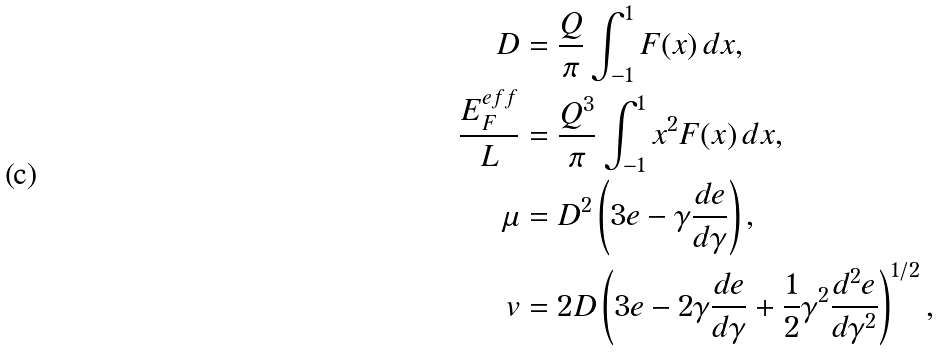Convert formula to latex. <formula><loc_0><loc_0><loc_500><loc_500>D & = \frac { Q } { \pi } \int _ { - 1 } ^ { 1 } F ( x ) \, d x , \\ \frac { E ^ { e f f } _ { F } } { L } & = \frac { Q ^ { 3 } } { \pi } \int _ { - 1 } ^ { 1 } x ^ { 2 } F ( x ) \, d x , \\ \mu & = D ^ { 2 } \left ( 3 e - \gamma \frac { d e } { d \gamma } \right ) , \\ v & = 2 D \left ( 3 e - 2 \gamma \frac { d e } { d \gamma } + \frac { 1 } { 2 } \gamma ^ { 2 } \frac { d ^ { 2 } e } { d \gamma ^ { 2 } } \right ) ^ { 1 / 2 } ,</formula> 